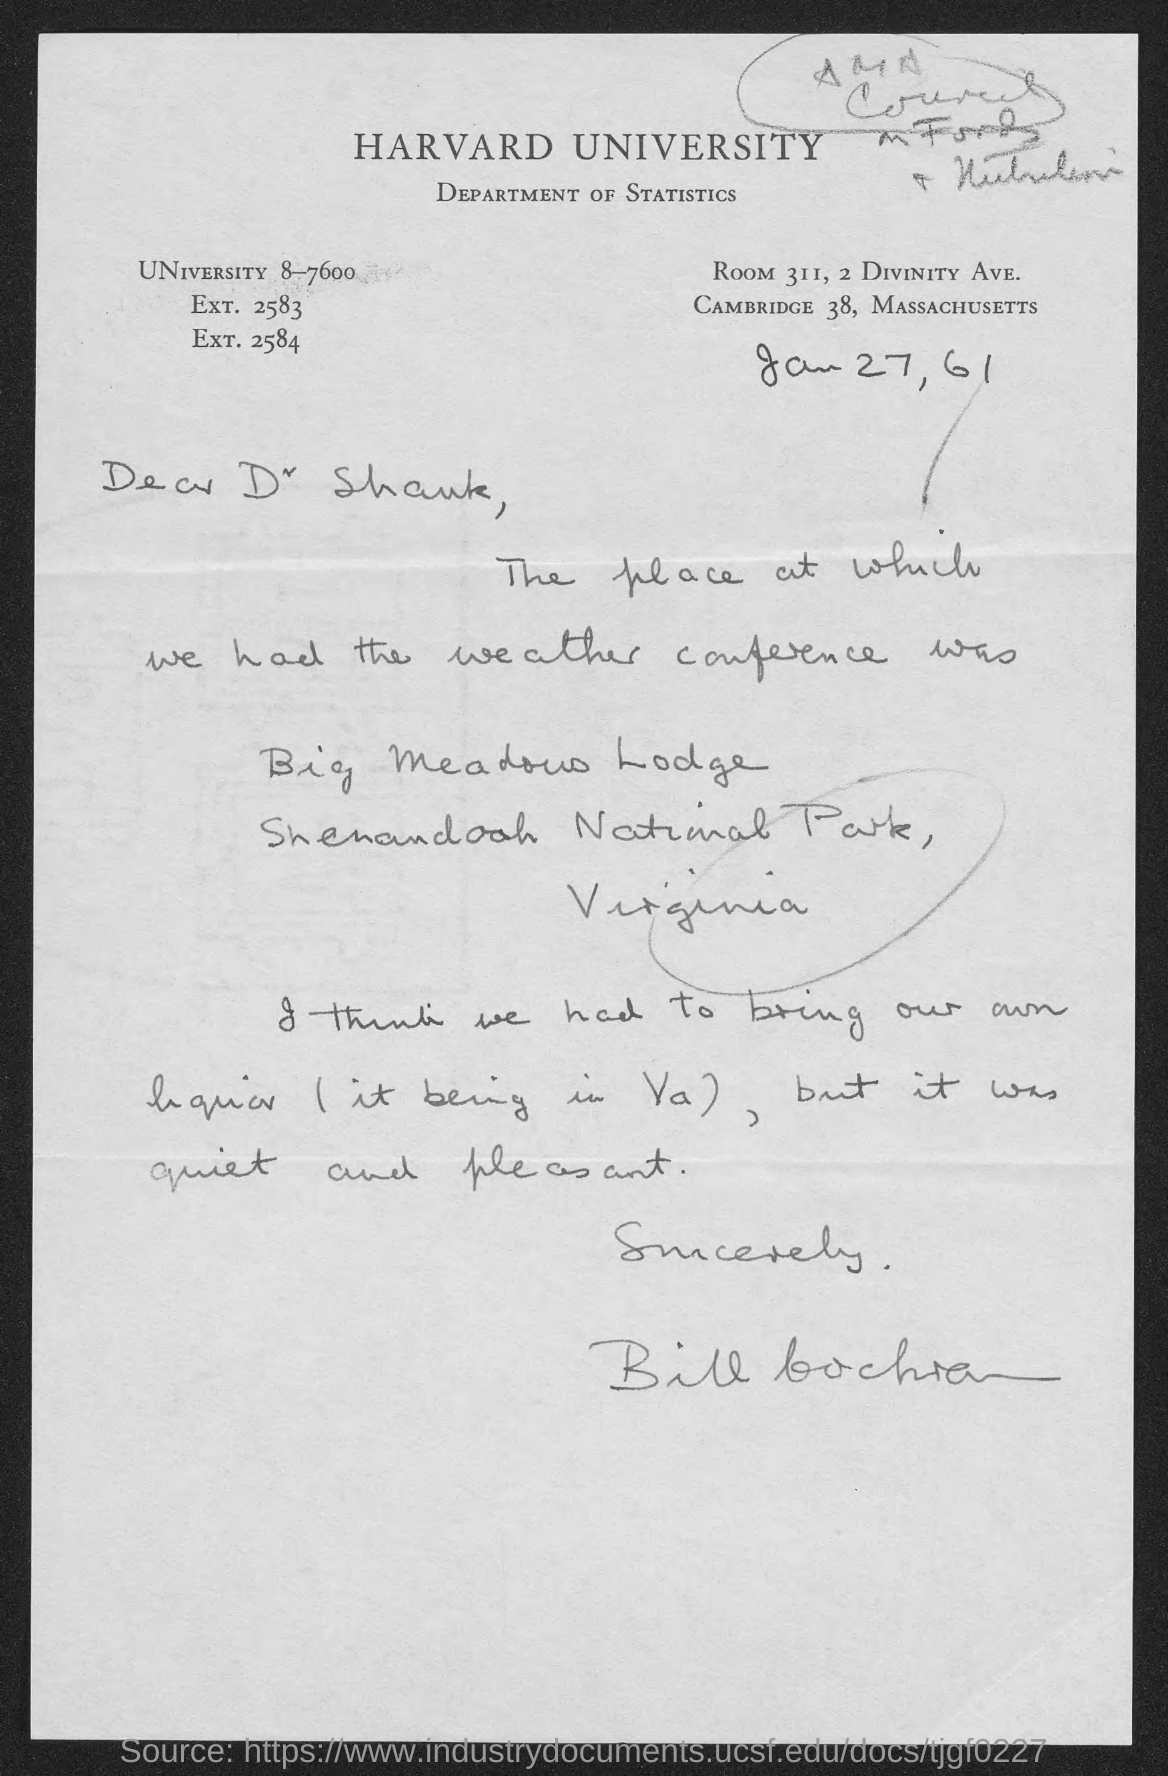Draw attention to some important aspects in this diagram. The letter is dated on January 27, 1961. The name of the university mentioned at the top of the page is Harvard University. The room number of the Department of Statistics is 311. This letter is written to Dr. Shank. 